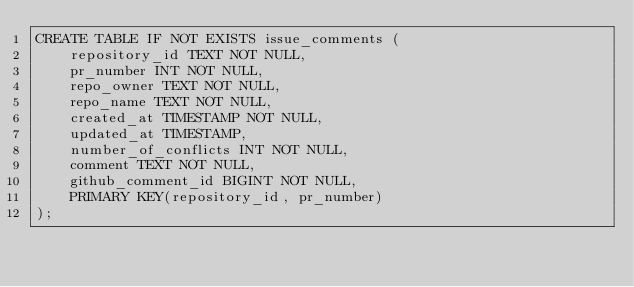Convert code to text. <code><loc_0><loc_0><loc_500><loc_500><_SQL_>CREATE TABLE IF NOT EXISTS issue_comments (
    repository_id TEXT NOT NULL,
    pr_number INT NOT NULL,
    repo_owner TEXT NOT NULL,
    repo_name TEXT NOT NULL,
    created_at TIMESTAMP NOT NULL,
    updated_at TIMESTAMP,
    number_of_conflicts INT NOT NULL,
    comment TEXT NOT NULL,
    github_comment_id BIGINT NOT NULL,
    PRIMARY KEY(repository_id, pr_number)
);</code> 